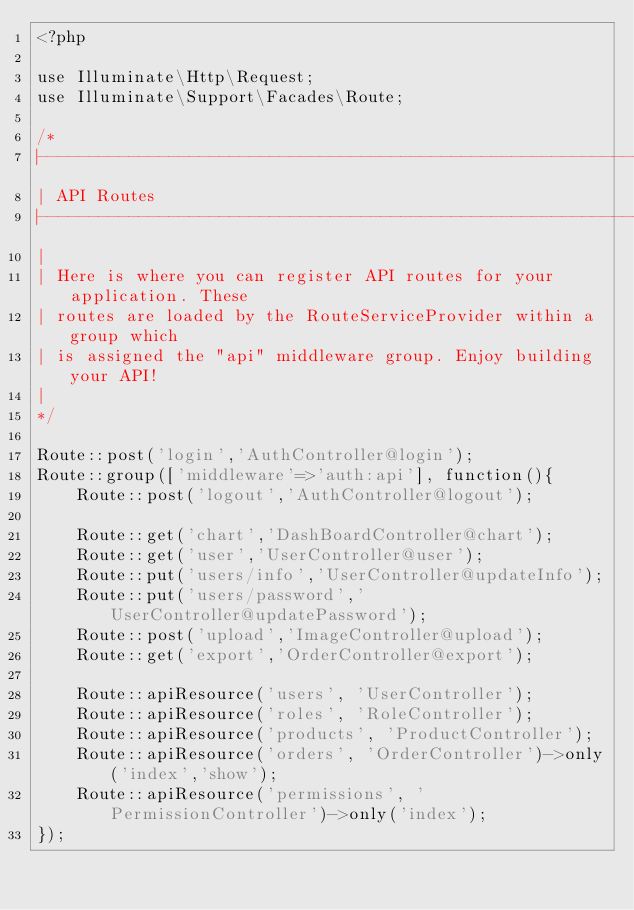Convert code to text. <code><loc_0><loc_0><loc_500><loc_500><_PHP_><?php

use Illuminate\Http\Request;
use Illuminate\Support\Facades\Route;

/*
|--------------------------------------------------------------------------
| API Routes
|--------------------------------------------------------------------------
|
| Here is where you can register API routes for your application. These
| routes are loaded by the RouteServiceProvider within a group which
| is assigned the "api" middleware group. Enjoy building your API!
|
*/

Route::post('login','AuthController@login');
Route::group(['middleware'=>'auth:api'], function(){
    Route::post('logout','AuthController@logout');

    Route::get('chart','DashBoardController@chart');
    Route::get('user','UserController@user');
    Route::put('users/info','UserController@updateInfo');
    Route::put('users/password','UserController@updatePassword');
    Route::post('upload','ImageController@upload');
    Route::get('export','OrderController@export');

    Route::apiResource('users', 'UserController');
    Route::apiResource('roles', 'RoleController');
    Route::apiResource('products', 'ProductController');
    Route::apiResource('orders', 'OrderController')->only('index','show');
    Route::apiResource('permissions', 'PermissionController')->only('index');
});

</code> 